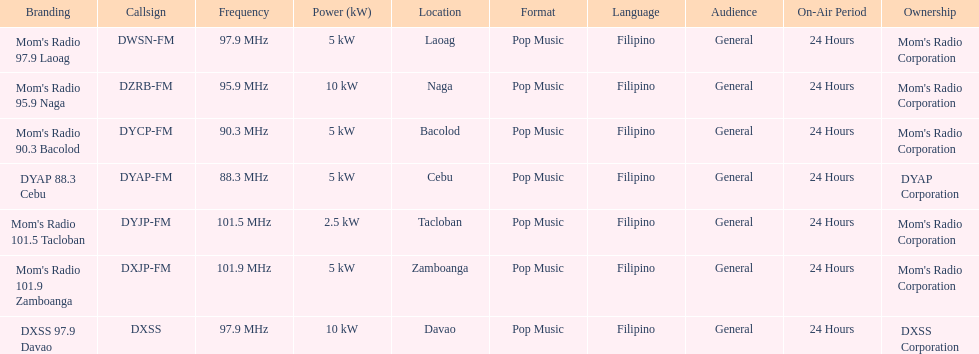How many stations have at least 5 kw or more listed in the power column? 6. Would you be able to parse every entry in this table? {'header': ['Branding', 'Callsign', 'Frequency', 'Power (kW)', 'Location', 'Format', 'Language', 'Audience', 'On-Air Period', 'Ownership'], 'rows': [["Mom's Radio 97.9 Laoag", 'DWSN-FM', '97.9\xa0MHz', '5\xa0kW', 'Laoag', 'Pop Music', 'Filipino', 'General', '24 Hours', "Mom's Radio Corporation"], ["Mom's Radio 95.9 Naga", 'DZRB-FM', '95.9\xa0MHz', '10\xa0kW', 'Naga', 'Pop Music', 'Filipino', 'General', '24 Hours', "Mom's Radio Corporation"], ["Mom's Radio 90.3 Bacolod", 'DYCP-FM', '90.3\xa0MHz', '5\xa0kW', 'Bacolod', 'Pop Music', 'Filipino', 'General', '24 Hours', "Mom's Radio Corporation"], ['DYAP 88.3 Cebu', 'DYAP-FM', '88.3\xa0MHz', '5\xa0kW', 'Cebu', 'Pop Music', 'Filipino', 'General', '24 Hours', 'DYAP Corporation'], ["Mom's Radio 101.5 Tacloban", 'DYJP-FM', '101.5\xa0MHz', '2.5\xa0kW', 'Tacloban', 'Pop Music', 'Filipino', 'General', '24 Hours', "Mom's Radio Corporation"], ["Mom's Radio 101.9 Zamboanga", 'DXJP-FM', '101.9\xa0MHz', '5\xa0kW', 'Zamboanga', 'Pop Music', 'Filipino', 'General', '24 Hours', "Mom's Radio Corporation"], ['DXSS 97.9 Davao', 'DXSS', '97.9\xa0MHz', '10\xa0kW', 'Davao', 'Pop Music', 'Filipino', 'General', '24 Hours', 'DXSS Corporation']]} 